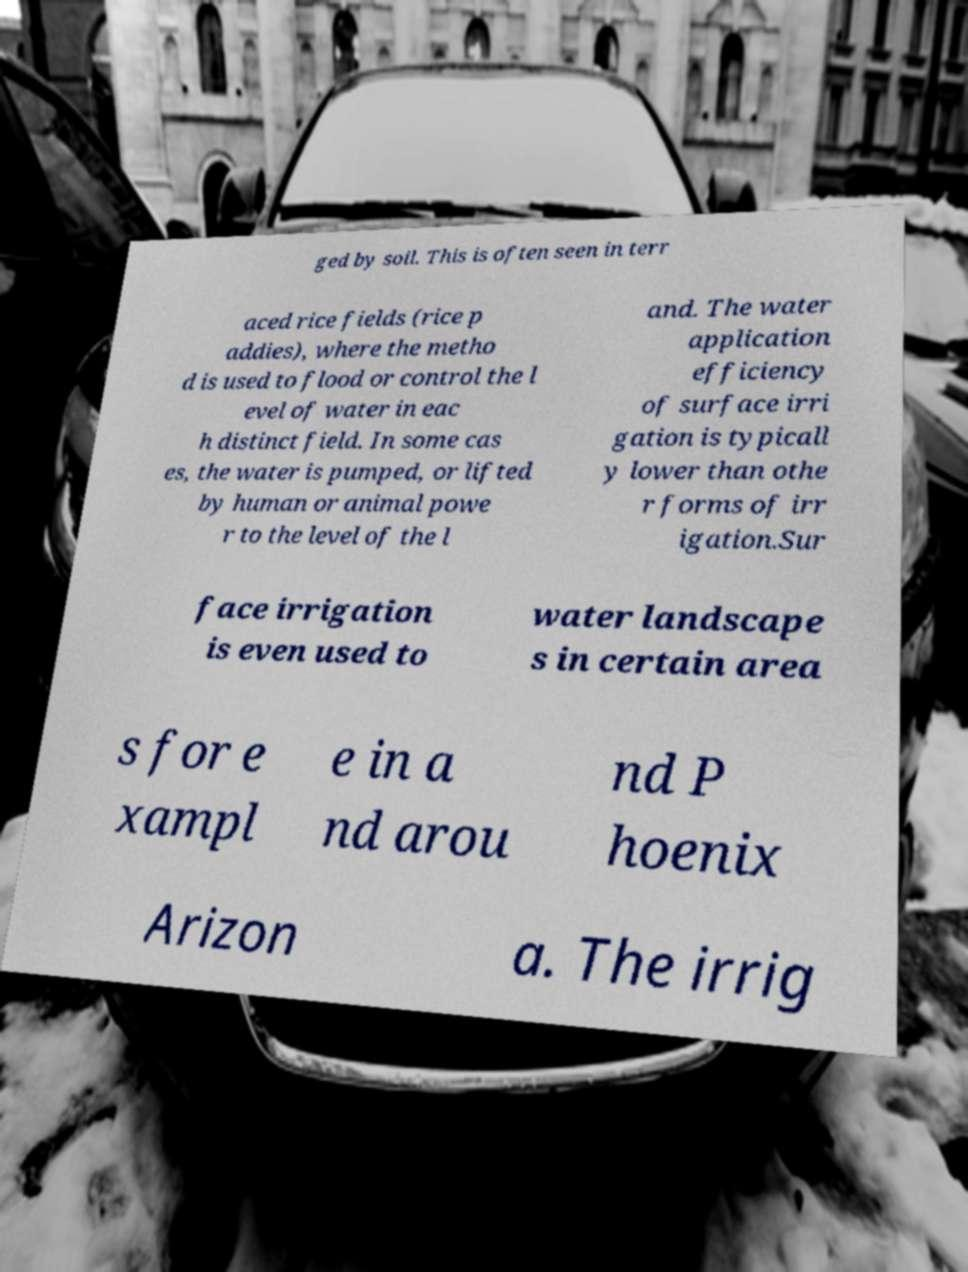I need the written content from this picture converted into text. Can you do that? ged by soil. This is often seen in terr aced rice fields (rice p addies), where the metho d is used to flood or control the l evel of water in eac h distinct field. In some cas es, the water is pumped, or lifted by human or animal powe r to the level of the l and. The water application efficiency of surface irri gation is typicall y lower than othe r forms of irr igation.Sur face irrigation is even used to water landscape s in certain area s for e xampl e in a nd arou nd P hoenix Arizon a. The irrig 